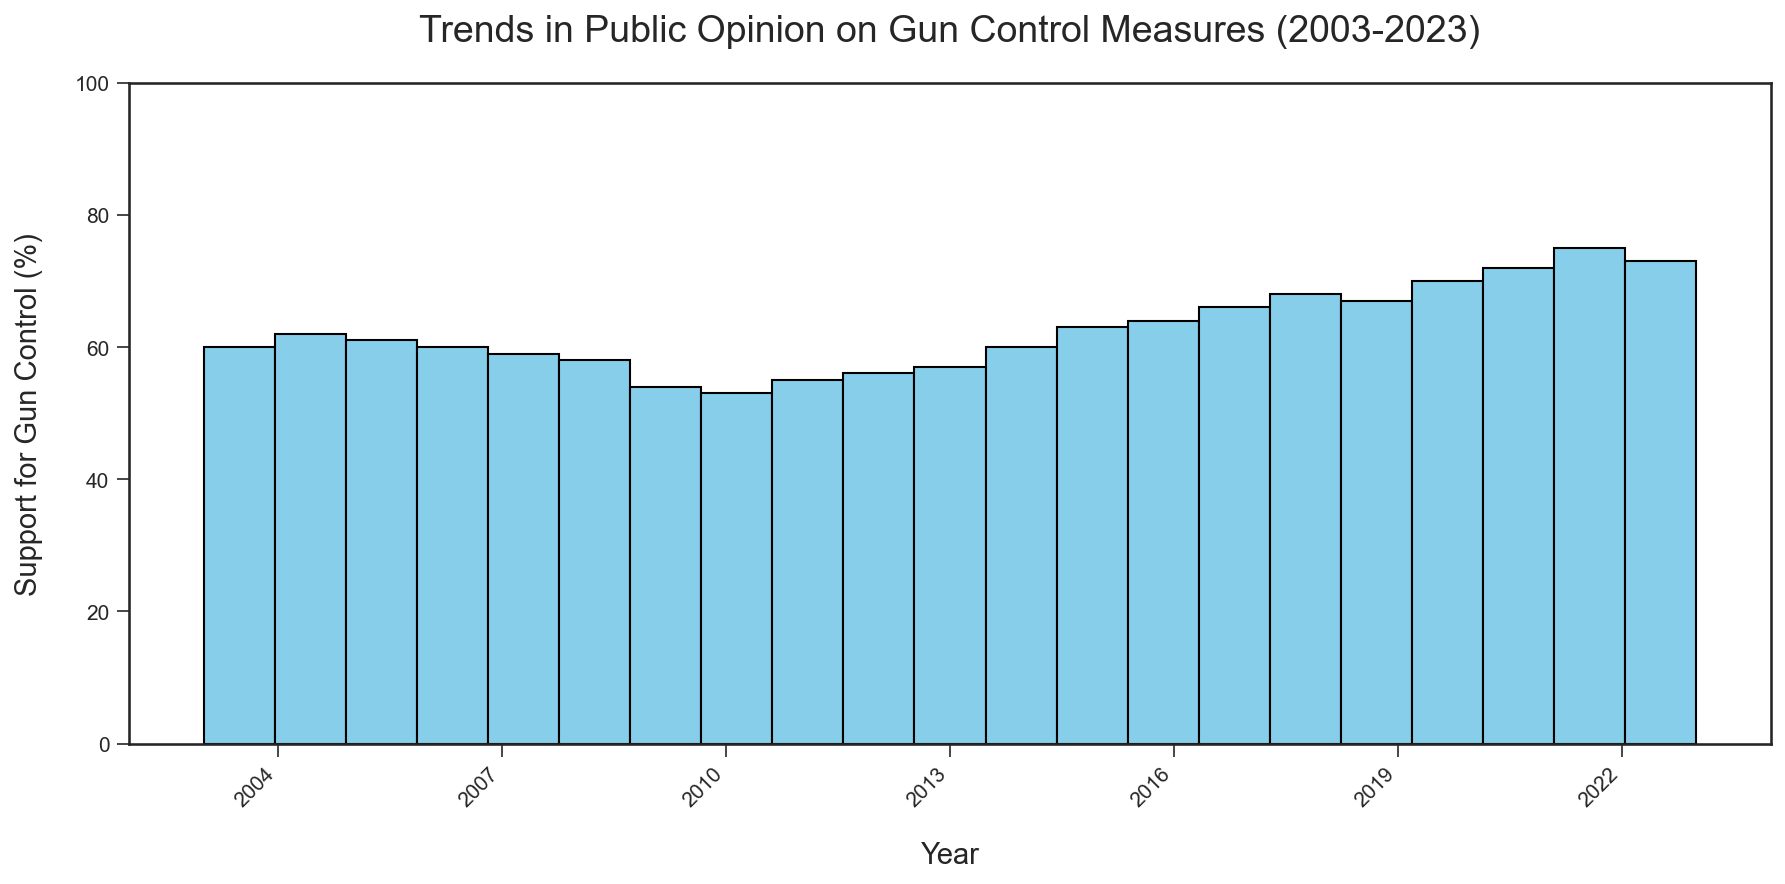How does the support for gun control in 2023 compare to that in 2003? By looking at the graph, we can see that the height of the bar for the year 2023 is higher than that for the year 2003. Specifically, support for gun control in 2023 is 73%, whereas in 2003, it was 60%.
Answer: Support in 2023 is 13% higher than in 2003 What is the trend in public opinion on gun control from 2015 to 2022? Observing the height of the bars from 2015 to 2022, we can see an increasing trend. Every successive year, the bar height increases. Specifically, support went from 63% in 2015 to 75% in 2022.
Answer: Increasing trend Which year had the highest support for gun control measures? By identifying the tallest bar in the histogram, we can see that the year with the highest support for gun control measures is 2022, with 75% support.
Answer: Year 2022 How did support for gun control change from 2009 to 2011? From the graph, we can see that in 2009, the support was at 54%, and in 2011, it increased to 55%. Therefore, the support increased by 1%.
Answer: Increased by 1% What is the average support for gun control measures between 2003 and 2008? To find the average, we sum the support percentages for the years 2003, 2004, 2005, 2006, 2007, and 2008, and then divide by the number of years. (60 + 62 + 61 + 60 + 59 + 58) / 6 = 360 / 6 = 60%.
Answer: 60% How many years had support for gun control measures greater than or equal to 70%? By counting the bars that reach or exceed the 70% height, we find three years: 2020, 2021, and 2022.
Answer: 3 years 